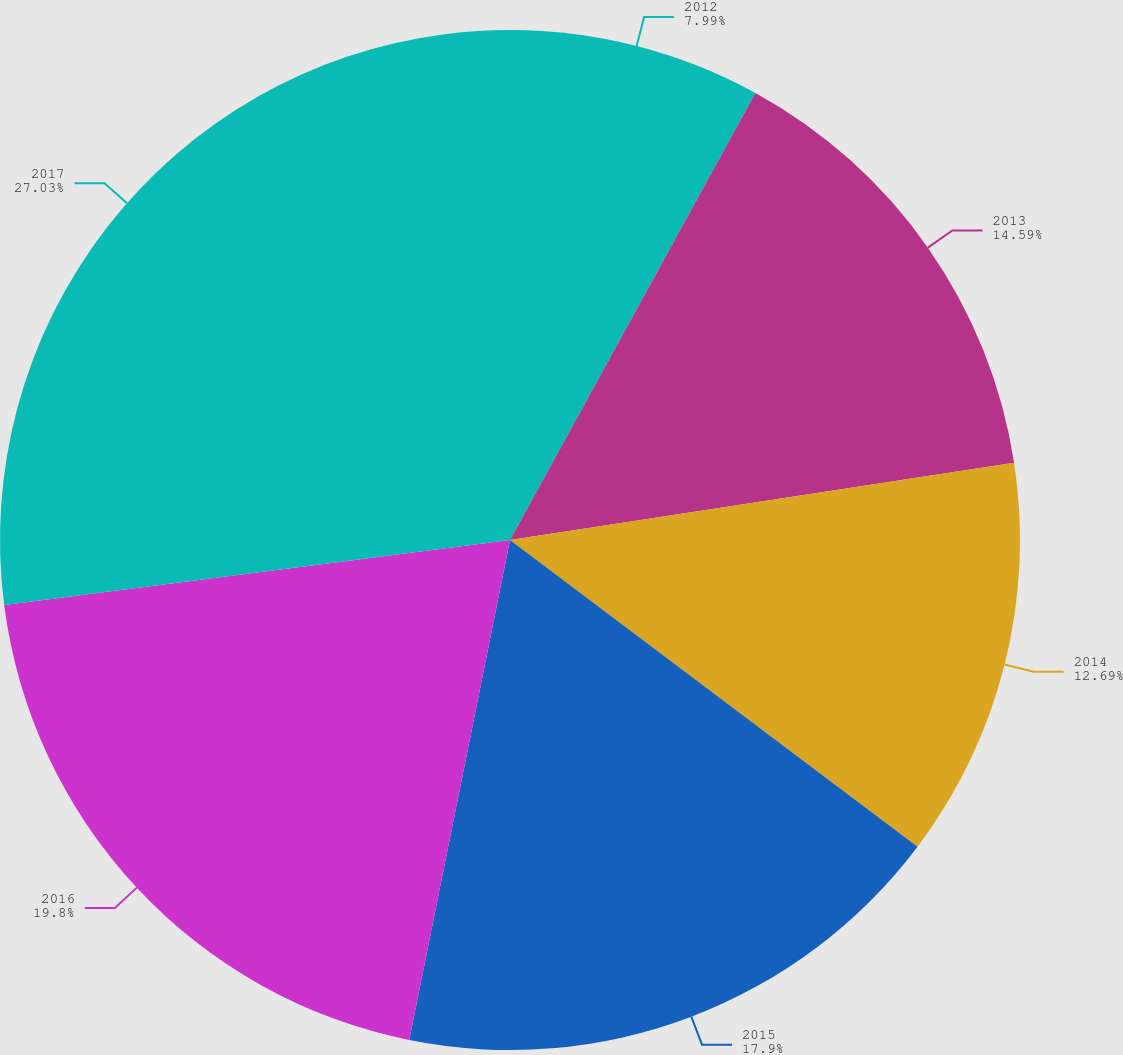Convert chart. <chart><loc_0><loc_0><loc_500><loc_500><pie_chart><fcel>2012<fcel>2013<fcel>2014<fcel>2015<fcel>2016<fcel>2017<nl><fcel>7.99%<fcel>14.59%<fcel>12.69%<fcel>17.9%<fcel>19.8%<fcel>27.04%<nl></chart> 